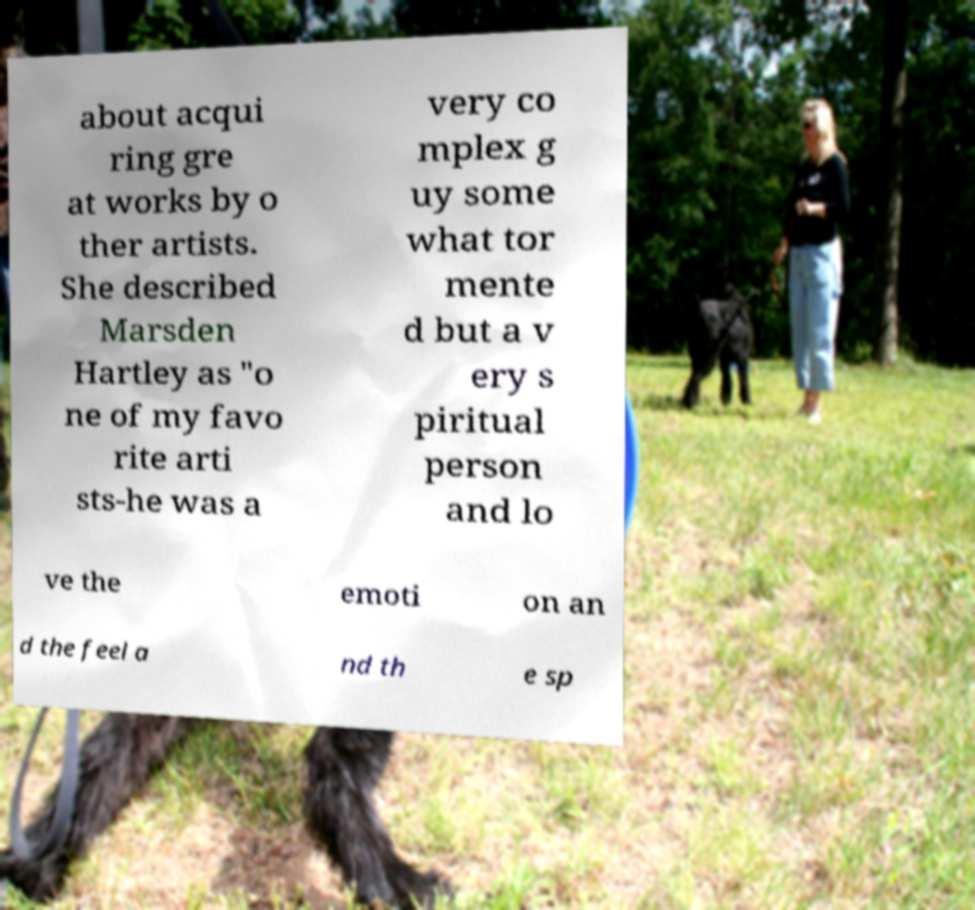What messages or text are displayed in this image? I need them in a readable, typed format. about acqui ring gre at works by o ther artists. She described Marsden Hartley as "o ne of my favo rite arti sts-he was a very co mplex g uy some what tor mente d but a v ery s piritual person and lo ve the emoti on an d the feel a nd th e sp 